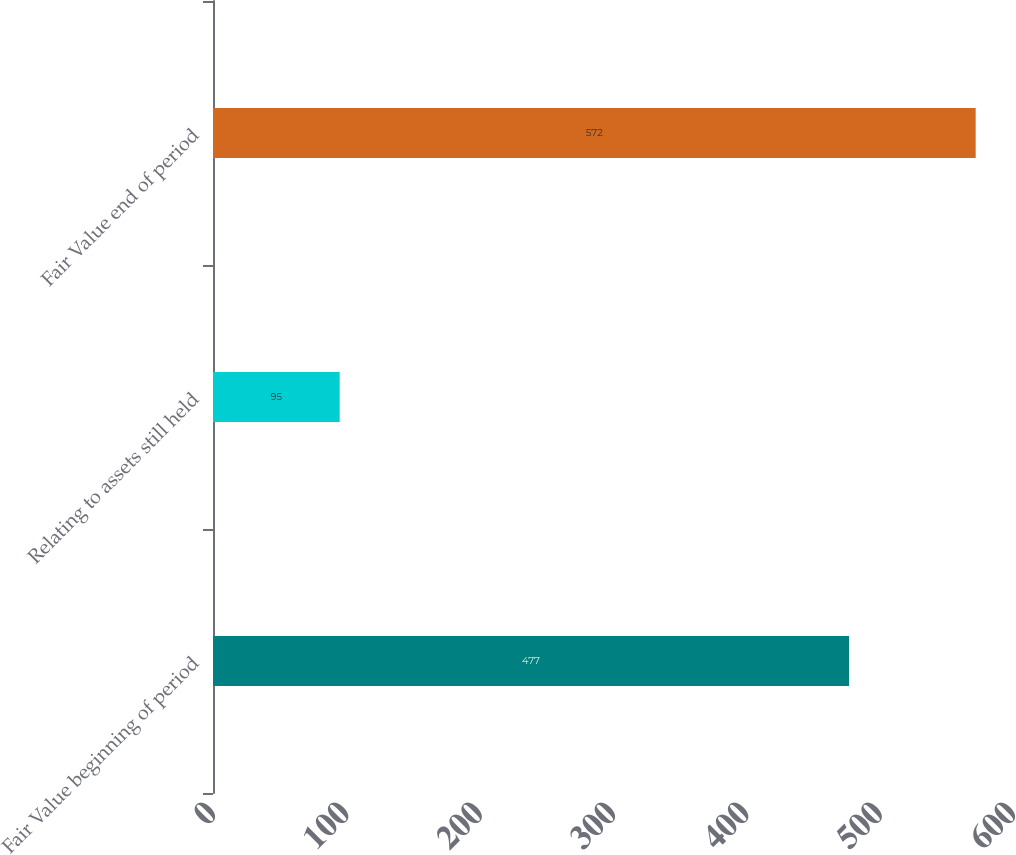Convert chart to OTSL. <chart><loc_0><loc_0><loc_500><loc_500><bar_chart><fcel>Fair Value beginning of period<fcel>Relating to assets still held<fcel>Fair Value end of period<nl><fcel>477<fcel>95<fcel>572<nl></chart> 